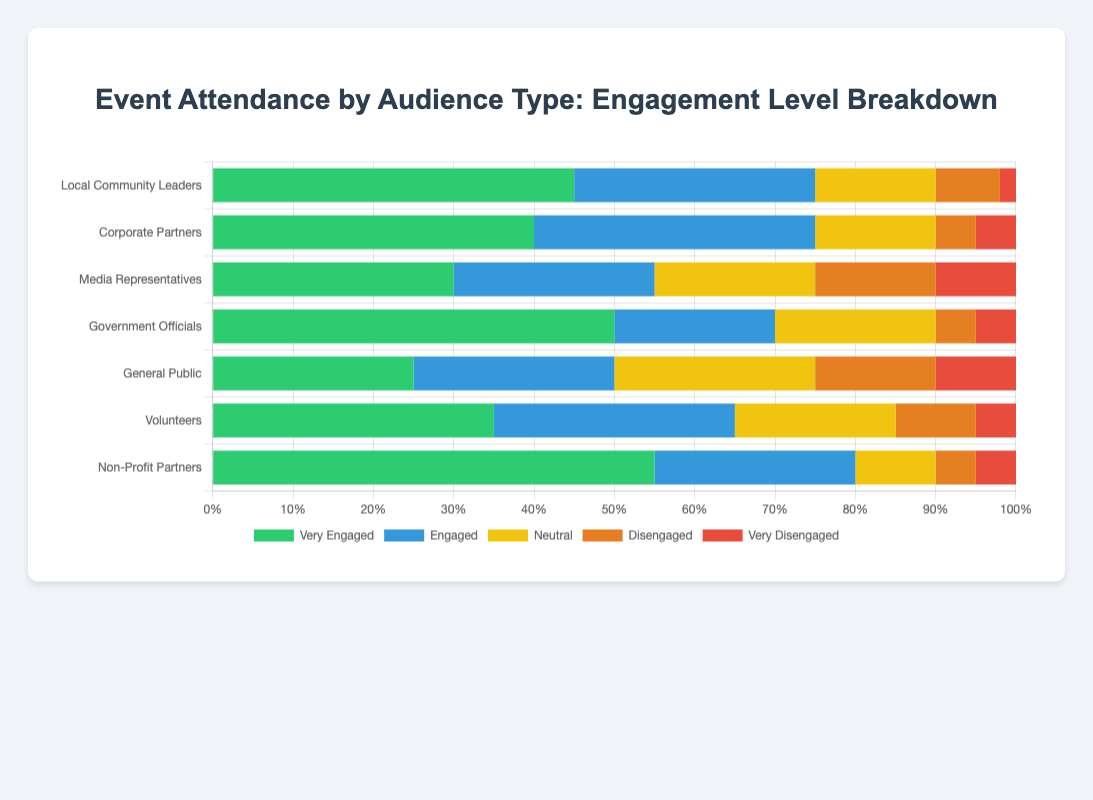Which audience type has the highest percentage of 'Very Engaged' attendees? The audience type with the highest percentage of 'Very Engaged' attendees can be identified by looking at the length of the green bars. 'Non-Profit Partners' have the longest green bar, indicating that they have the highest percentage of 'Very Engaged' attendees.
Answer: Non-Profit Partners How many audience types have over 50% engagement if combining 'Very Engaged' and 'Engaged' levels? To find the number of audience types with over 50% engagement, sum the percentages of 'Very Engaged' and 'Engaged' for each audience type and count those that exceed 50%. 'Local Community Leaders', 'Corporate Partners', 'Non-Profit Partners', and 'Government Officials' meet this criterion.
Answer: 4 Which audience type has the most 'Disengaged' and 'Very Disengaged' attendees combined? To determine this, sum the 'Disengaged' and 'Very Disengaged' percentages for each audience type and identify which sum is the highest. 'Media Representatives' have the highest combined total of 25% (15% 'Disengaged' + 10% 'Very Disengaged').
Answer: Media Representatives What is the average percentage of 'Neutral' attendees across all audience types? To calculate the average, sum the percentages of 'Neutral' attendees across all audience types and divide by the number of audience types (15 + 15 + 20 + 20 + 25 + 20 + 10 = 125; 125 / 7 ≈ 17.86).
Answer: 17.86% Which group has a higher percentage of 'Engaged' attendees, 'Volunteers' or 'Corporate Partners'? Compare the blue bars representing 'Engaged' percentages for 'Volunteers' (30%) and 'Corporate Partners' (35%). The longer blue bar corresponds to the higher percentage.
Answer: Corporate Partners What is the total percentage of 'Very Engaged' attendees for 'Local Community Leaders' and 'Government Officials'? Sum the percentages of 'Very Engaged' attendees for 'Local Community Leaders' (45%) and 'Government Officials' (50%) to get the total.
Answer: 95% Which audience type has the smallest percentage of 'Very Disengaged' attendees? Look for the shortest red bar that represents 'Very Disengaged' attendees. 'Local Community Leaders' have the shortest red bar at 2%.
Answer: Local Community Leaders Between 'General Public' and 'Volunteers', which group has a higher percentage of 'Neutral' attendees and by how much? Subtract the 'Neutral' percentage of 'Volunteers' (20%) from that of 'General Public' (25%). 25% - 20% = 5%.
Answer: General Public by 5% Which audience type has the most balanced distribution of engagement levels? The audience type with the most balanced distribution will have bars of more equal length across all engagement levels. 'General Public' shows relatively equal bars for each engagement level.
Answer: General Public Comparing 'Engaged' attendees across all types, which audience type ranks second? Examine the lengths of the blue bars (Engaged) and rank them. 'Corporate Partners' have the highest at 35%, followed by 'Local Community Leaders' at 30%.
Answer: Local Community Leaders 